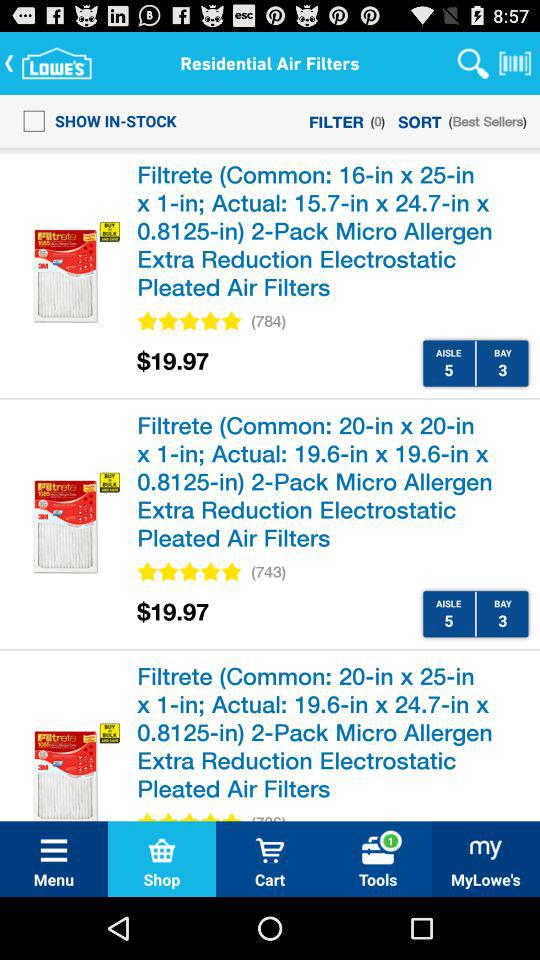How many reviews does the first product have?
Answer the question using a single word or phrase. 784 